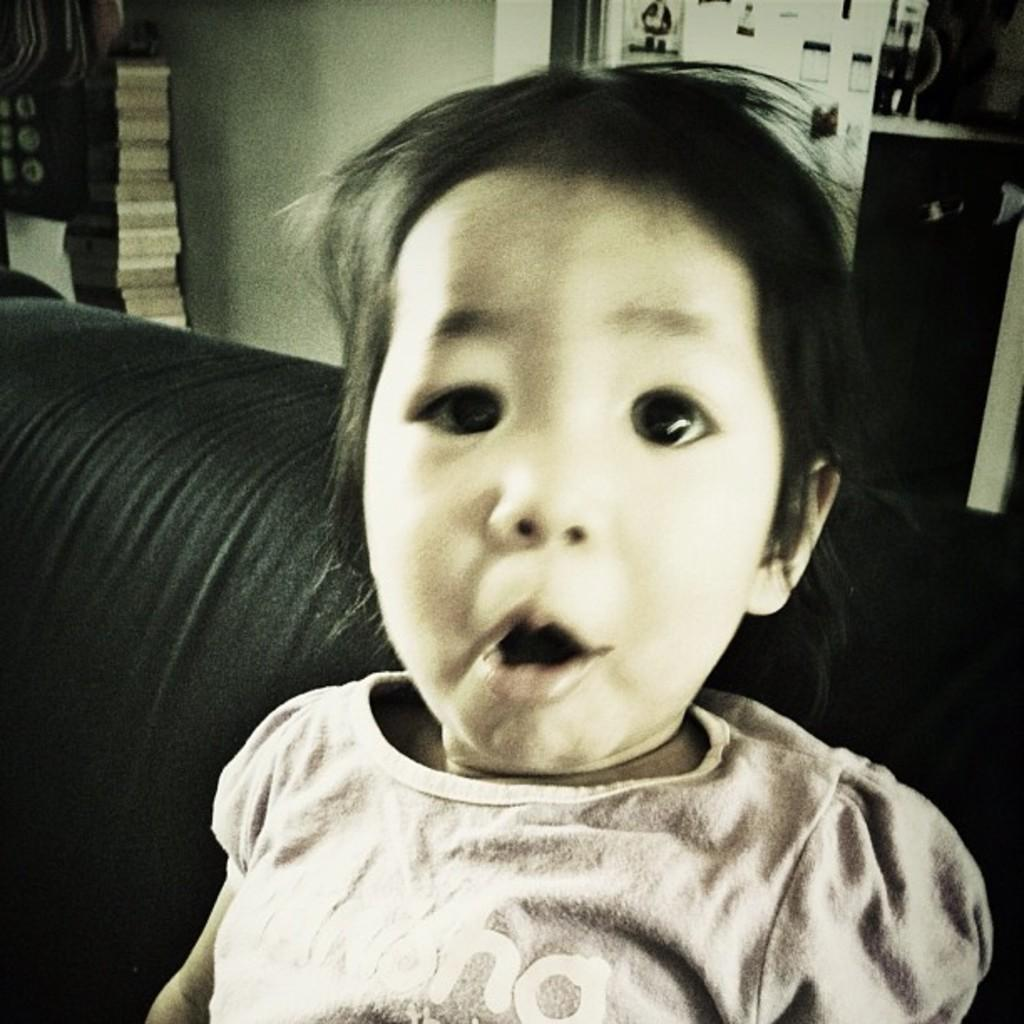What is the main subject of the image? There is a child in the image. What can be seen in the background of the image? There is a wall in the background of the image. Are there any other objects visible in the background? Yes, there are some unspecified objects in the background of the image. What type of base is supporting the child in the image? There is no base visible in the image, and the child is not shown to be supported by any object. 